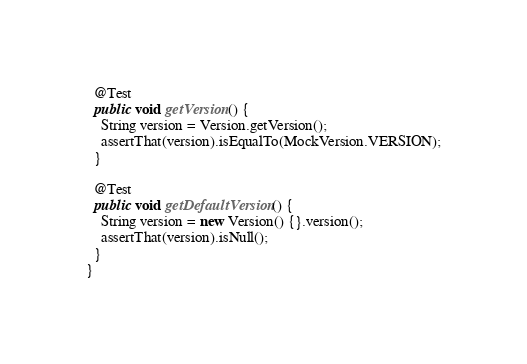<code> <loc_0><loc_0><loc_500><loc_500><_Java_>
  @Test
  public void getVersion() {
    String version = Version.getVersion();
    assertThat(version).isEqualTo(MockVersion.VERSION);
  }

  @Test
  public void getDefaultVersion() {
    String version = new Version() {}.version();
    assertThat(version).isNull();
  }
}
</code> 